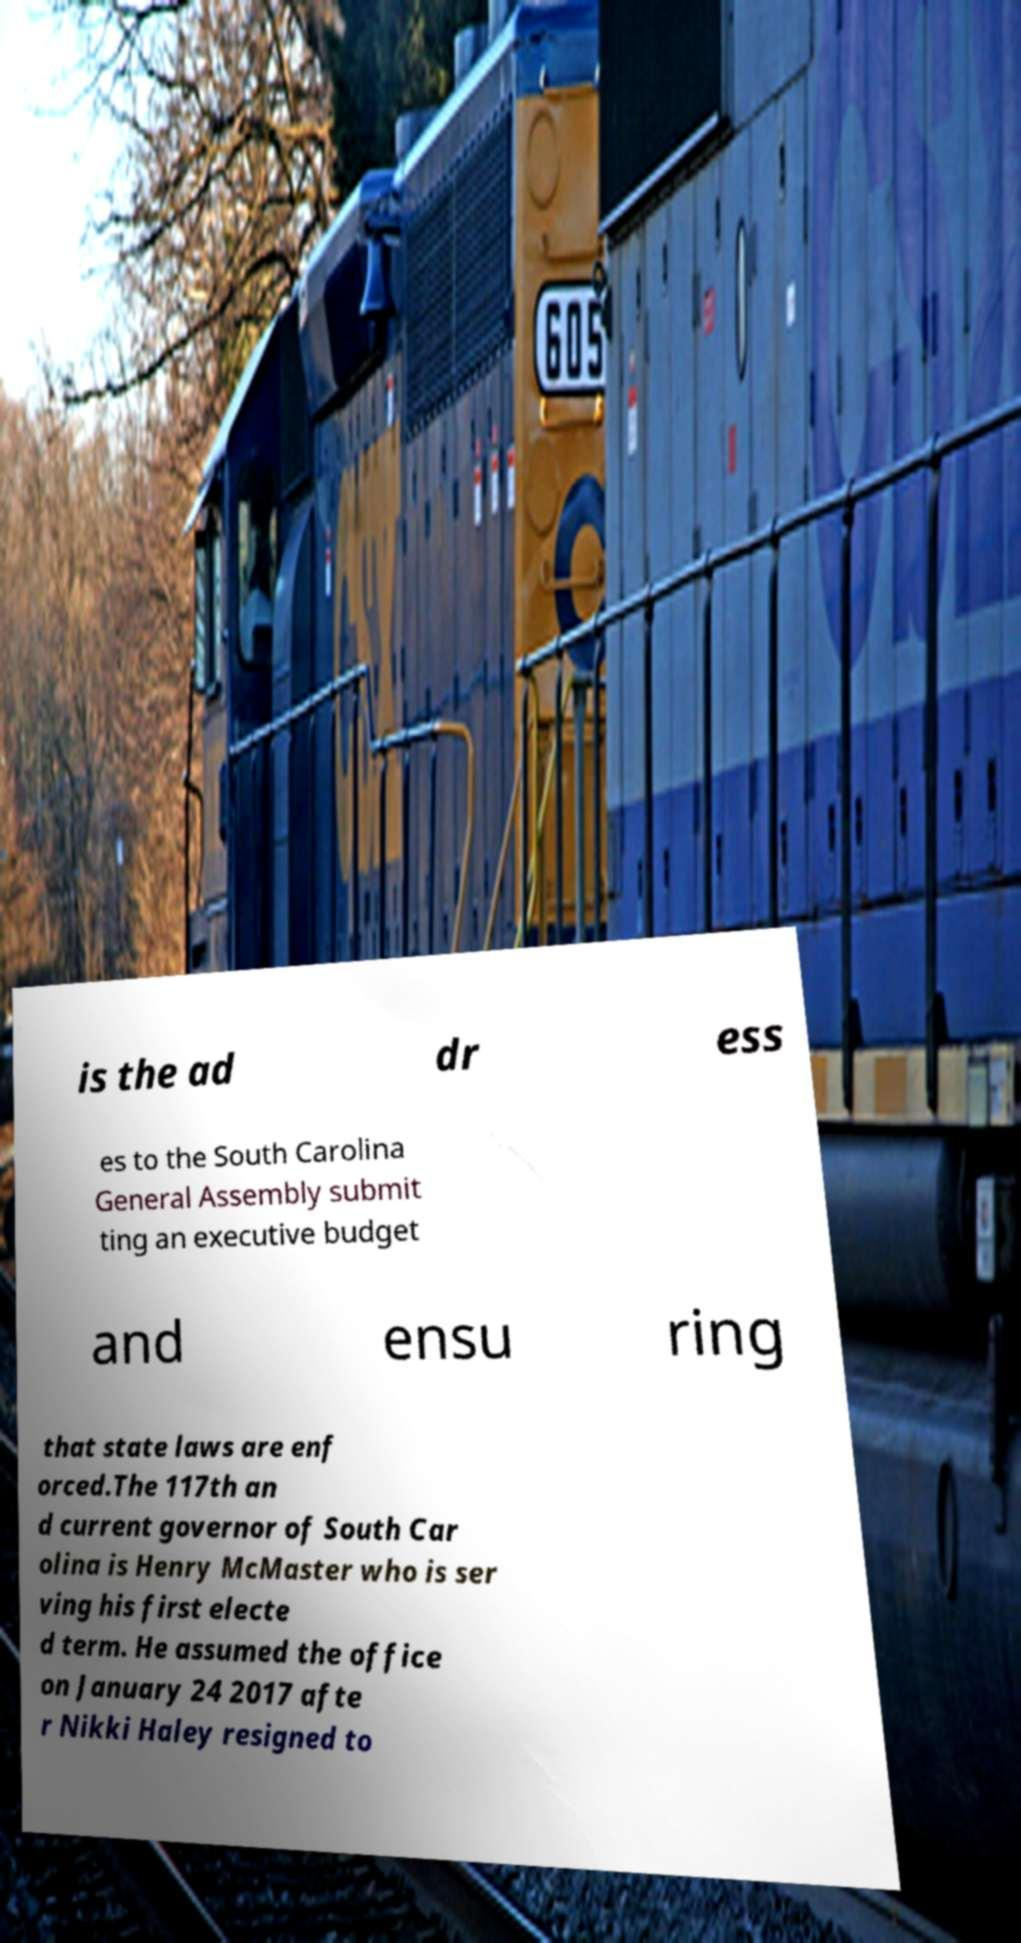Please identify and transcribe the text found in this image. is the ad dr ess es to the South Carolina General Assembly submit ting an executive budget and ensu ring that state laws are enf orced.The 117th an d current governor of South Car olina is Henry McMaster who is ser ving his first electe d term. He assumed the office on January 24 2017 afte r Nikki Haley resigned to 